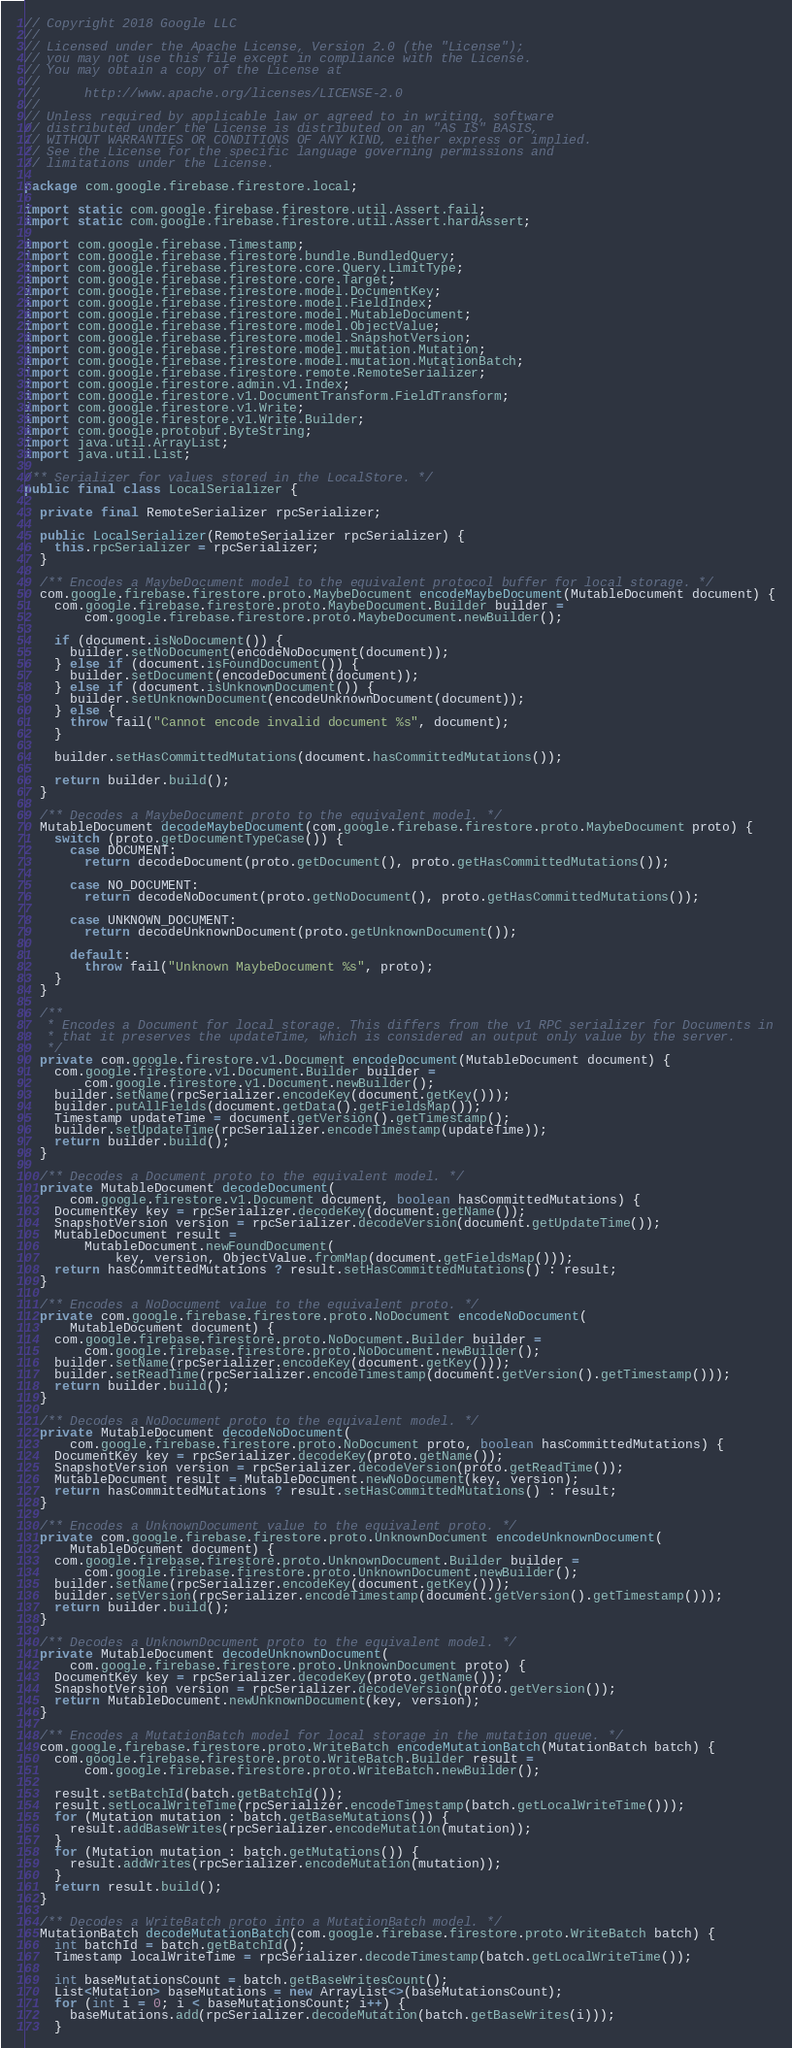<code> <loc_0><loc_0><loc_500><loc_500><_Java_>// Copyright 2018 Google LLC
//
// Licensed under the Apache License, Version 2.0 (the "License");
// you may not use this file except in compliance with the License.
// You may obtain a copy of the License at
//
//      http://www.apache.org/licenses/LICENSE-2.0
//
// Unless required by applicable law or agreed to in writing, software
// distributed under the License is distributed on an "AS IS" BASIS,
// WITHOUT WARRANTIES OR CONDITIONS OF ANY KIND, either express or implied.
// See the License for the specific language governing permissions and
// limitations under the License.

package com.google.firebase.firestore.local;

import static com.google.firebase.firestore.util.Assert.fail;
import static com.google.firebase.firestore.util.Assert.hardAssert;

import com.google.firebase.Timestamp;
import com.google.firebase.firestore.bundle.BundledQuery;
import com.google.firebase.firestore.core.Query.LimitType;
import com.google.firebase.firestore.core.Target;
import com.google.firebase.firestore.model.DocumentKey;
import com.google.firebase.firestore.model.FieldIndex;
import com.google.firebase.firestore.model.MutableDocument;
import com.google.firebase.firestore.model.ObjectValue;
import com.google.firebase.firestore.model.SnapshotVersion;
import com.google.firebase.firestore.model.mutation.Mutation;
import com.google.firebase.firestore.model.mutation.MutationBatch;
import com.google.firebase.firestore.remote.RemoteSerializer;
import com.google.firestore.admin.v1.Index;
import com.google.firestore.v1.DocumentTransform.FieldTransform;
import com.google.firestore.v1.Write;
import com.google.firestore.v1.Write.Builder;
import com.google.protobuf.ByteString;
import java.util.ArrayList;
import java.util.List;

/** Serializer for values stored in the LocalStore. */
public final class LocalSerializer {

  private final RemoteSerializer rpcSerializer;

  public LocalSerializer(RemoteSerializer rpcSerializer) {
    this.rpcSerializer = rpcSerializer;
  }

  /** Encodes a MaybeDocument model to the equivalent protocol buffer for local storage. */
  com.google.firebase.firestore.proto.MaybeDocument encodeMaybeDocument(MutableDocument document) {
    com.google.firebase.firestore.proto.MaybeDocument.Builder builder =
        com.google.firebase.firestore.proto.MaybeDocument.newBuilder();

    if (document.isNoDocument()) {
      builder.setNoDocument(encodeNoDocument(document));
    } else if (document.isFoundDocument()) {
      builder.setDocument(encodeDocument(document));
    } else if (document.isUnknownDocument()) {
      builder.setUnknownDocument(encodeUnknownDocument(document));
    } else {
      throw fail("Cannot encode invalid document %s", document);
    }

    builder.setHasCommittedMutations(document.hasCommittedMutations());

    return builder.build();
  }

  /** Decodes a MaybeDocument proto to the equivalent model. */
  MutableDocument decodeMaybeDocument(com.google.firebase.firestore.proto.MaybeDocument proto) {
    switch (proto.getDocumentTypeCase()) {
      case DOCUMENT:
        return decodeDocument(proto.getDocument(), proto.getHasCommittedMutations());

      case NO_DOCUMENT:
        return decodeNoDocument(proto.getNoDocument(), proto.getHasCommittedMutations());

      case UNKNOWN_DOCUMENT:
        return decodeUnknownDocument(proto.getUnknownDocument());

      default:
        throw fail("Unknown MaybeDocument %s", proto);
    }
  }

  /**
   * Encodes a Document for local storage. This differs from the v1 RPC serializer for Documents in
   * that it preserves the updateTime, which is considered an output only value by the server.
   */
  private com.google.firestore.v1.Document encodeDocument(MutableDocument document) {
    com.google.firestore.v1.Document.Builder builder =
        com.google.firestore.v1.Document.newBuilder();
    builder.setName(rpcSerializer.encodeKey(document.getKey()));
    builder.putAllFields(document.getData().getFieldsMap());
    Timestamp updateTime = document.getVersion().getTimestamp();
    builder.setUpdateTime(rpcSerializer.encodeTimestamp(updateTime));
    return builder.build();
  }

  /** Decodes a Document proto to the equivalent model. */
  private MutableDocument decodeDocument(
      com.google.firestore.v1.Document document, boolean hasCommittedMutations) {
    DocumentKey key = rpcSerializer.decodeKey(document.getName());
    SnapshotVersion version = rpcSerializer.decodeVersion(document.getUpdateTime());
    MutableDocument result =
        MutableDocument.newFoundDocument(
            key, version, ObjectValue.fromMap(document.getFieldsMap()));
    return hasCommittedMutations ? result.setHasCommittedMutations() : result;
  }

  /** Encodes a NoDocument value to the equivalent proto. */
  private com.google.firebase.firestore.proto.NoDocument encodeNoDocument(
      MutableDocument document) {
    com.google.firebase.firestore.proto.NoDocument.Builder builder =
        com.google.firebase.firestore.proto.NoDocument.newBuilder();
    builder.setName(rpcSerializer.encodeKey(document.getKey()));
    builder.setReadTime(rpcSerializer.encodeTimestamp(document.getVersion().getTimestamp()));
    return builder.build();
  }

  /** Decodes a NoDocument proto to the equivalent model. */
  private MutableDocument decodeNoDocument(
      com.google.firebase.firestore.proto.NoDocument proto, boolean hasCommittedMutations) {
    DocumentKey key = rpcSerializer.decodeKey(proto.getName());
    SnapshotVersion version = rpcSerializer.decodeVersion(proto.getReadTime());
    MutableDocument result = MutableDocument.newNoDocument(key, version);
    return hasCommittedMutations ? result.setHasCommittedMutations() : result;
  }

  /** Encodes a UnknownDocument value to the equivalent proto. */
  private com.google.firebase.firestore.proto.UnknownDocument encodeUnknownDocument(
      MutableDocument document) {
    com.google.firebase.firestore.proto.UnknownDocument.Builder builder =
        com.google.firebase.firestore.proto.UnknownDocument.newBuilder();
    builder.setName(rpcSerializer.encodeKey(document.getKey()));
    builder.setVersion(rpcSerializer.encodeTimestamp(document.getVersion().getTimestamp()));
    return builder.build();
  }

  /** Decodes a UnknownDocument proto to the equivalent model. */
  private MutableDocument decodeUnknownDocument(
      com.google.firebase.firestore.proto.UnknownDocument proto) {
    DocumentKey key = rpcSerializer.decodeKey(proto.getName());
    SnapshotVersion version = rpcSerializer.decodeVersion(proto.getVersion());
    return MutableDocument.newUnknownDocument(key, version);
  }

  /** Encodes a MutationBatch model for local storage in the mutation queue. */
  com.google.firebase.firestore.proto.WriteBatch encodeMutationBatch(MutationBatch batch) {
    com.google.firebase.firestore.proto.WriteBatch.Builder result =
        com.google.firebase.firestore.proto.WriteBatch.newBuilder();

    result.setBatchId(batch.getBatchId());
    result.setLocalWriteTime(rpcSerializer.encodeTimestamp(batch.getLocalWriteTime()));
    for (Mutation mutation : batch.getBaseMutations()) {
      result.addBaseWrites(rpcSerializer.encodeMutation(mutation));
    }
    for (Mutation mutation : batch.getMutations()) {
      result.addWrites(rpcSerializer.encodeMutation(mutation));
    }
    return result.build();
  }

  /** Decodes a WriteBatch proto into a MutationBatch model. */
  MutationBatch decodeMutationBatch(com.google.firebase.firestore.proto.WriteBatch batch) {
    int batchId = batch.getBatchId();
    Timestamp localWriteTime = rpcSerializer.decodeTimestamp(batch.getLocalWriteTime());

    int baseMutationsCount = batch.getBaseWritesCount();
    List<Mutation> baseMutations = new ArrayList<>(baseMutationsCount);
    for (int i = 0; i < baseMutationsCount; i++) {
      baseMutations.add(rpcSerializer.decodeMutation(batch.getBaseWrites(i)));
    }
</code> 